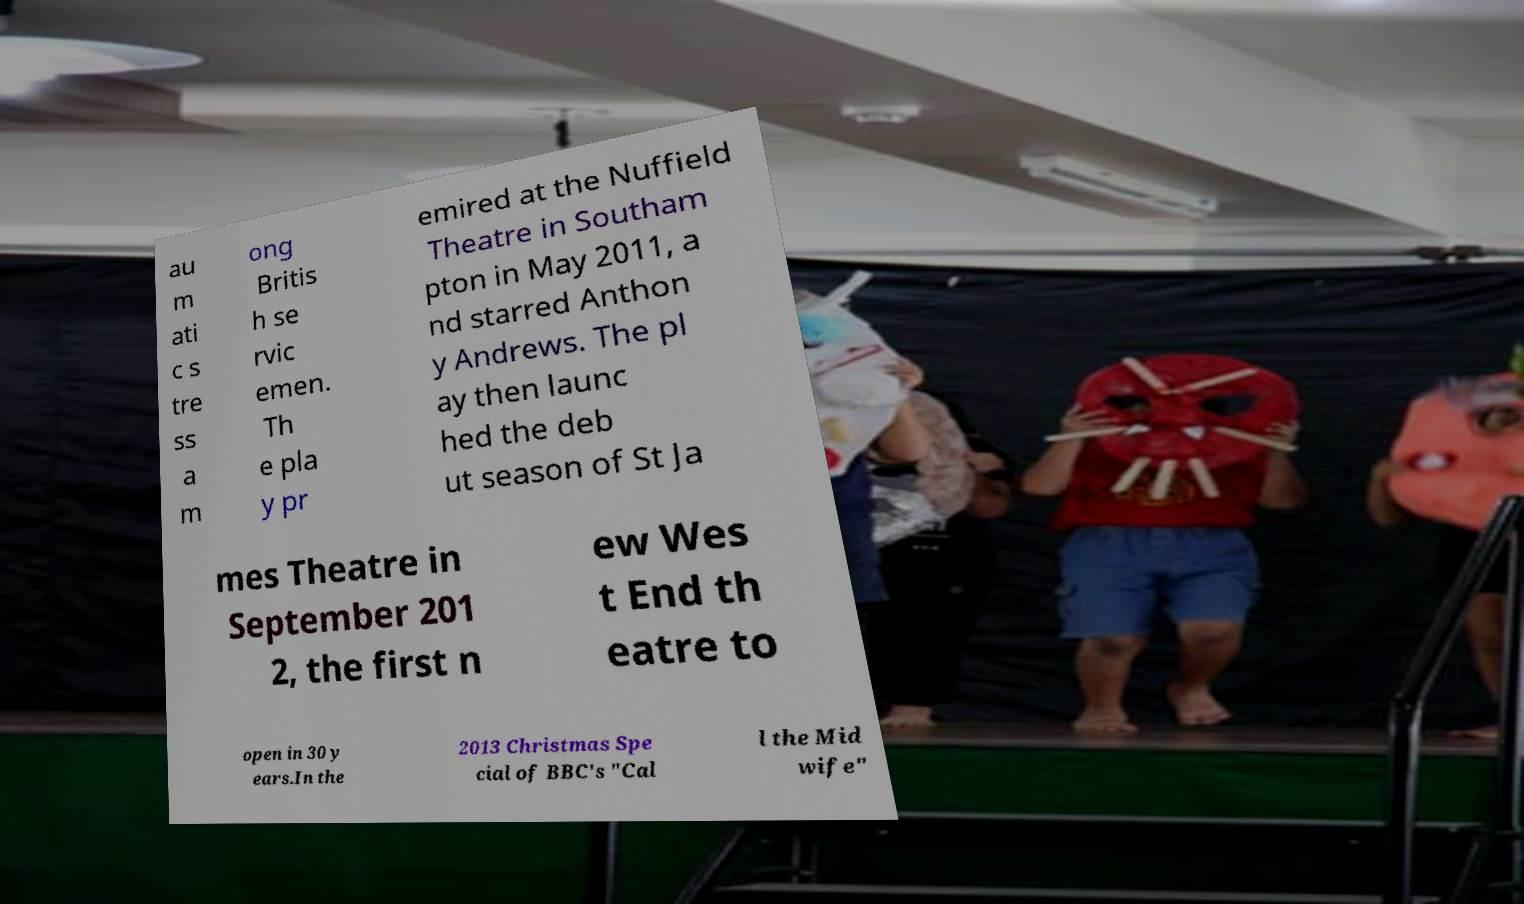Can you read and provide the text displayed in the image?This photo seems to have some interesting text. Can you extract and type it out for me? au m ati c s tre ss a m ong Britis h se rvic emen. Th e pla y pr emired at the Nuffield Theatre in Southam pton in May 2011, a nd starred Anthon y Andrews. The pl ay then launc hed the deb ut season of St Ja mes Theatre in September 201 2, the first n ew Wes t End th eatre to open in 30 y ears.In the 2013 Christmas Spe cial of BBC's "Cal l the Mid wife" 